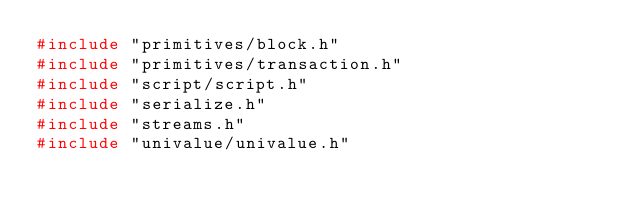Convert code to text. <code><loc_0><loc_0><loc_500><loc_500><_C++_>#include "primitives/block.h"
#include "primitives/transaction.h"
#include "script/script.h"
#include "serialize.h"
#include "streams.h"
#include "univalue/univalue.h"</code> 